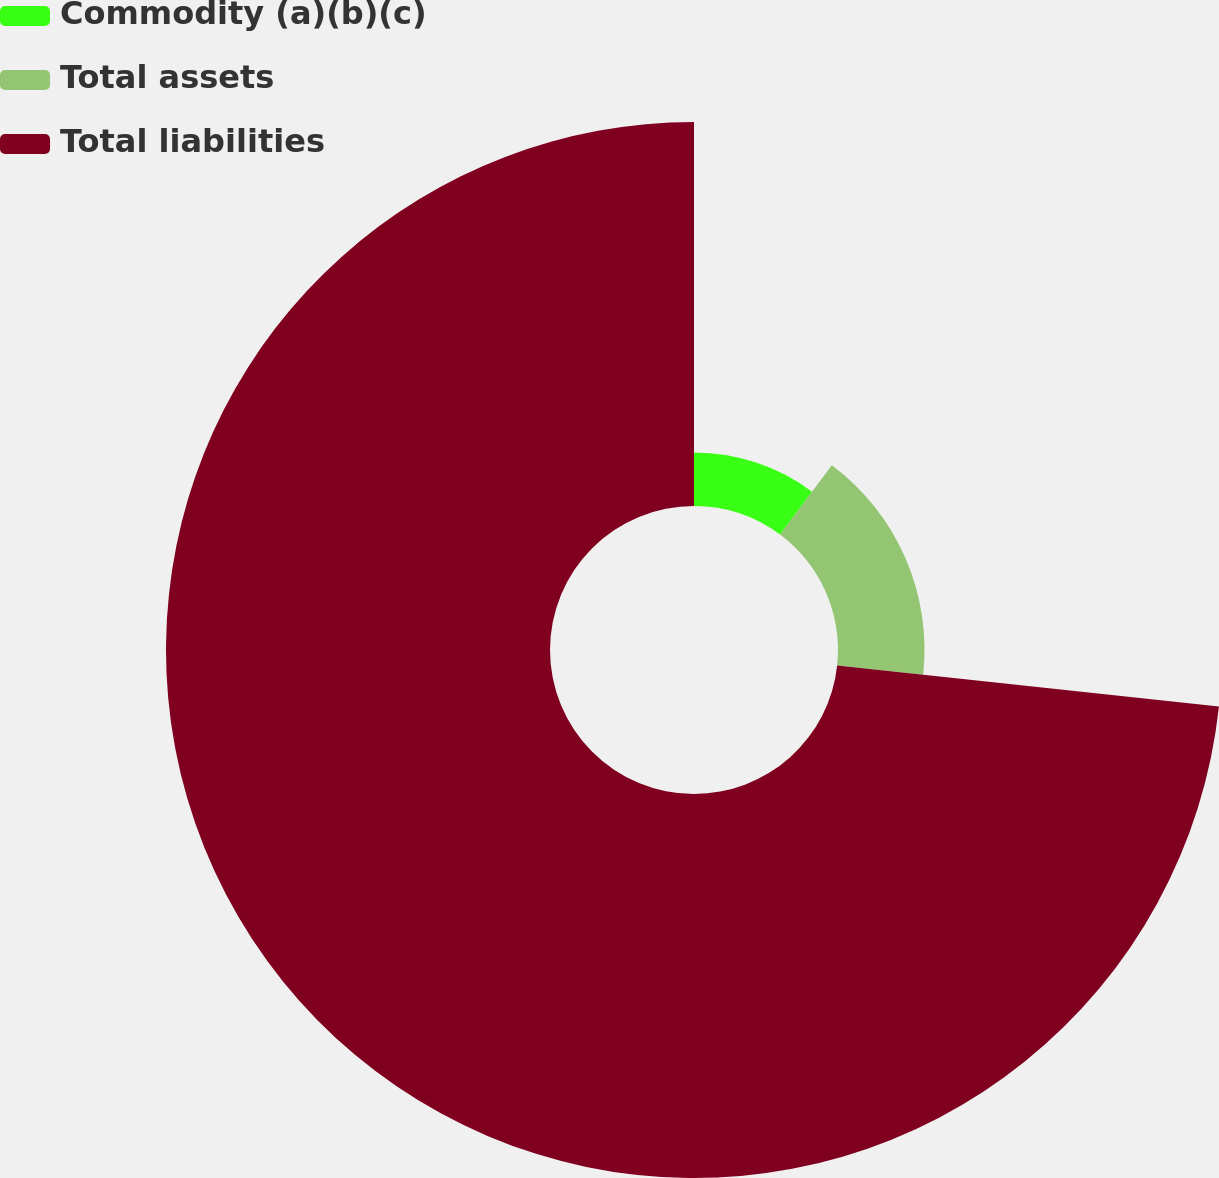<chart> <loc_0><loc_0><loc_500><loc_500><pie_chart><fcel>Commodity (a)(b)(c)<fcel>Total assets<fcel>Total liabilities<nl><fcel>10.2%<fcel>16.51%<fcel>73.29%<nl></chart> 